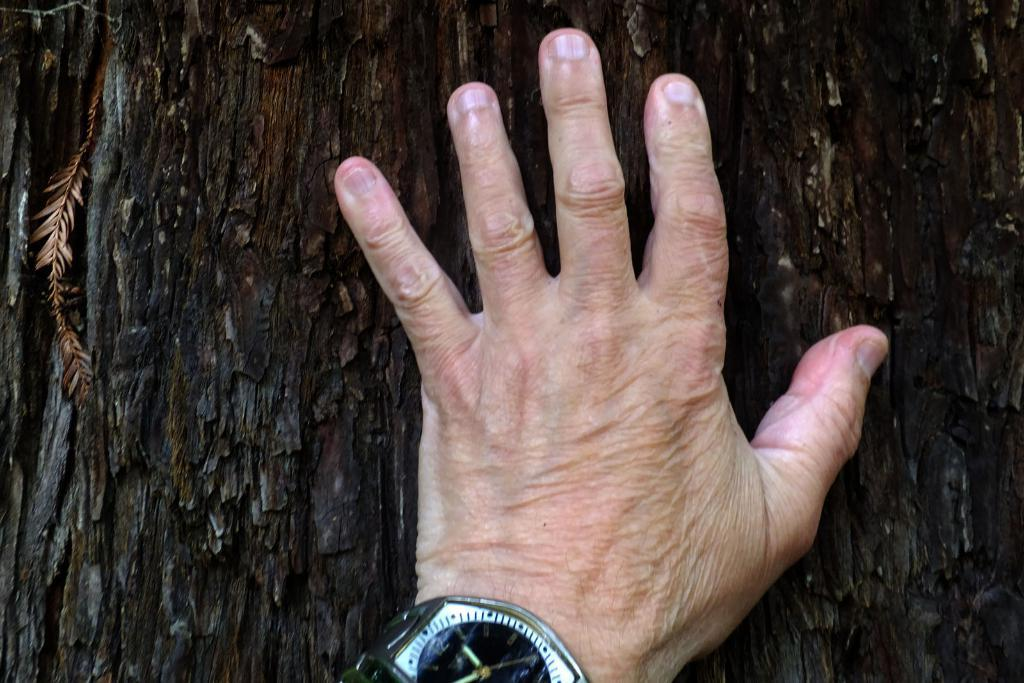What part of an old man is visible in the image? There is an old man's hand in the image. What accessory is the old man wearing on his hand? The old man is wearing a watch. What natural element can be seen in the background of the image? There is a trunk of a tree in the background of the image. What colors are present on the trunk of the tree? The trunk of the tree has brown and black colors. What type of camp can be seen in the image? There is no camp present in the image; it features an old man's hand, a watch, and a tree trunk in the background. 